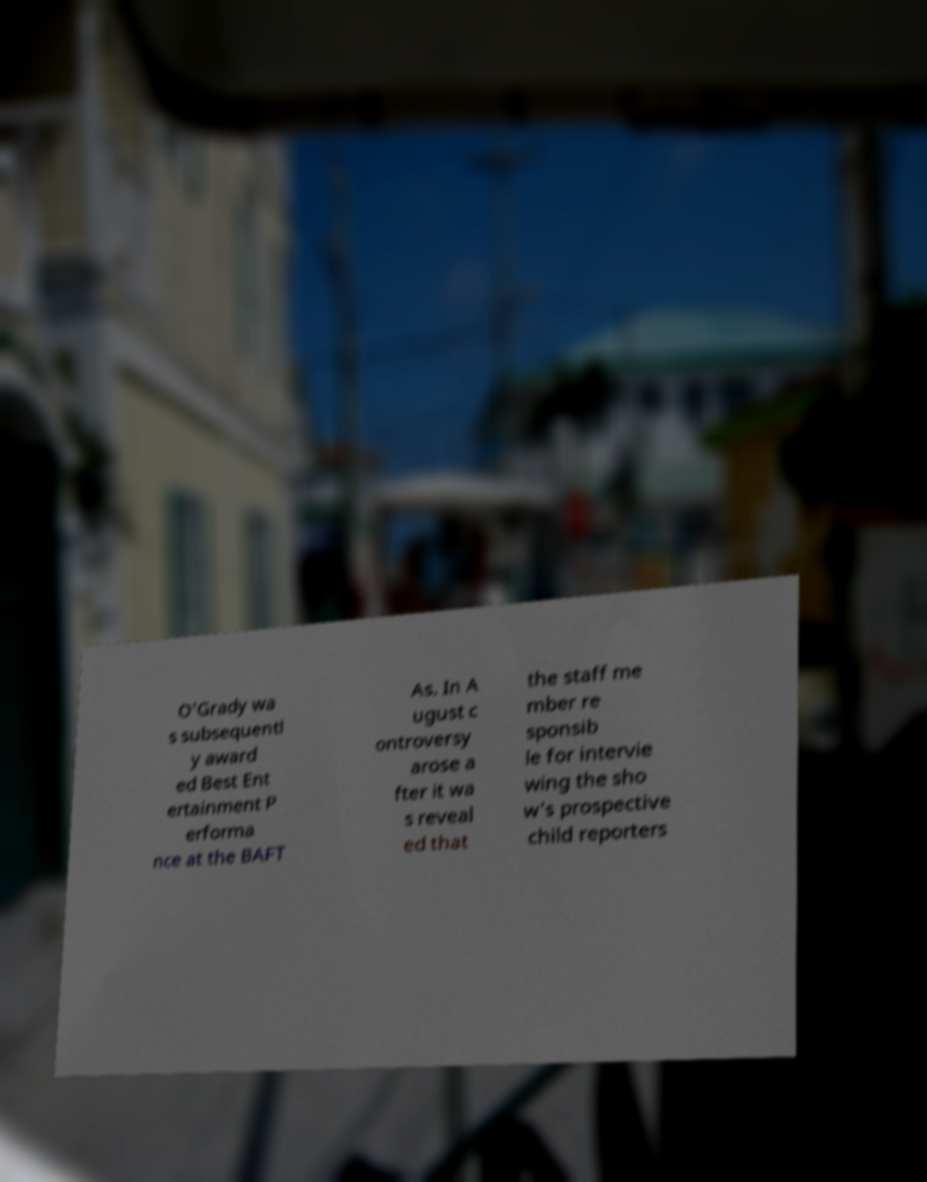Can you read and provide the text displayed in the image?This photo seems to have some interesting text. Can you extract and type it out for me? O'Grady wa s subsequentl y award ed Best Ent ertainment P erforma nce at the BAFT As. In A ugust c ontroversy arose a fter it wa s reveal ed that the staff me mber re sponsib le for intervie wing the sho w's prospective child reporters 